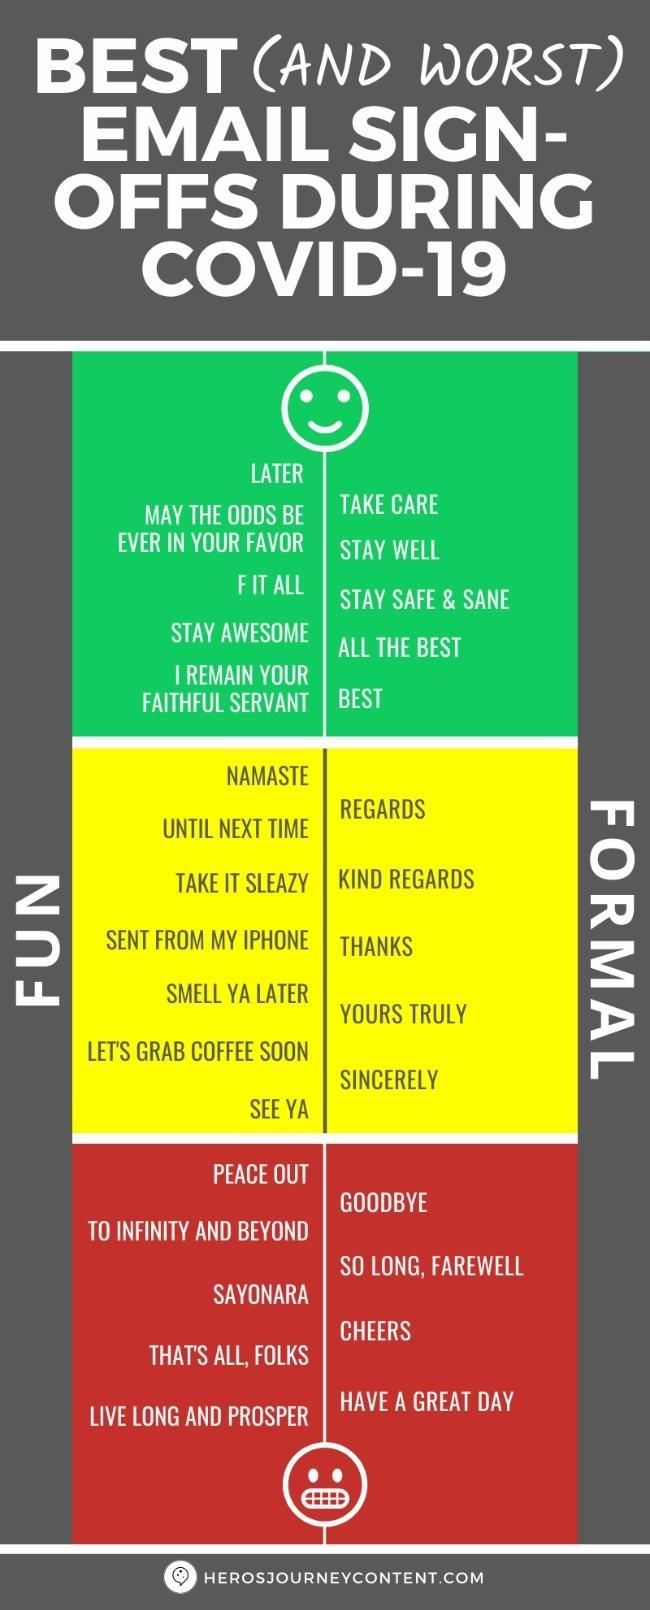Which one of the following is not under the "Fun" category - cheers, stay awesome, I remain or see ya?
Answer the question with a short phrase. cheers Which one of the following is not under the "Formal" category - regards, namaste, sincerely or thanks? namaste 